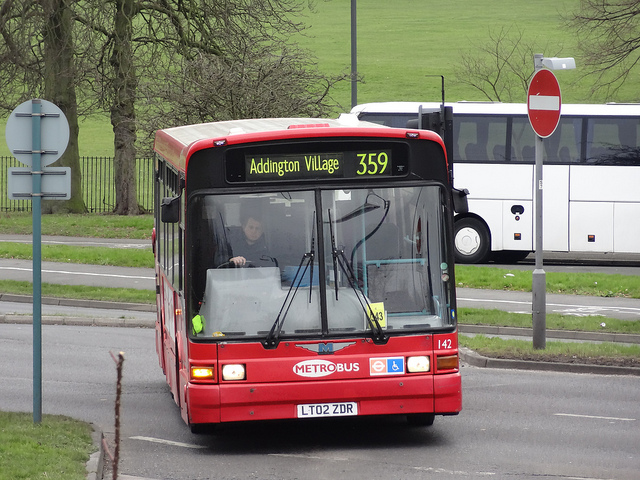Please transcribe the text in this image. Addington Village 359 METRO BUS ZDR LT02 142 43 